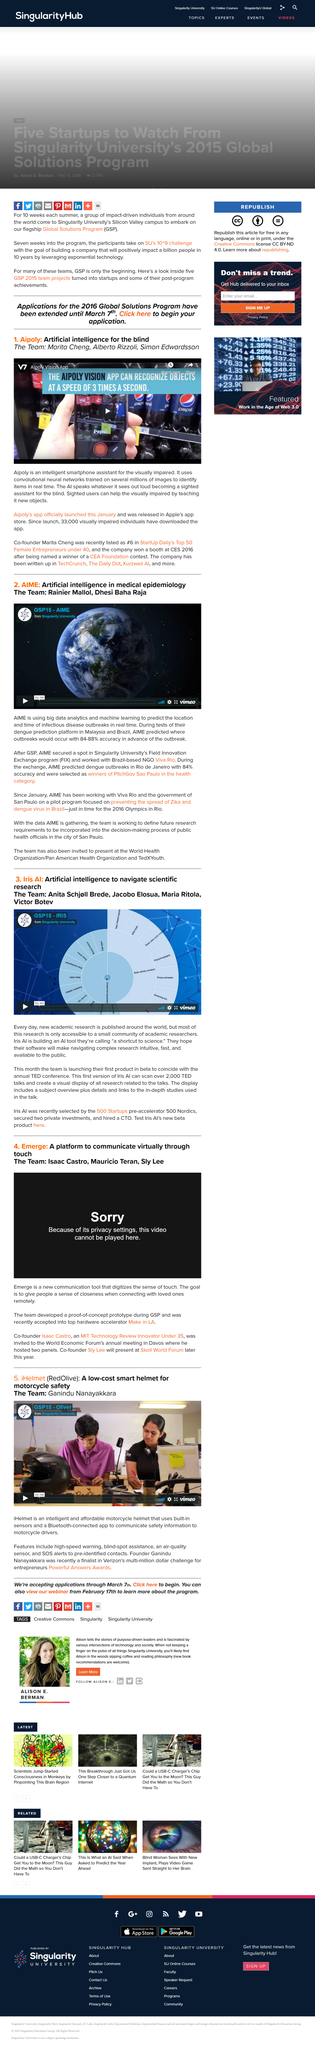Identify some key points in this picture. It has been confirmed that Sly Lee will be presenting "Emerge" at the Skoll World Forum later this year. The AIME utilizes big data analytics and machine learning to accurately predict the location and timing of infectious disease outbreaks in real time, allowing for effective prevention and control measures to be implemented. The iHelmet is a low cost smart helmet that utilizes built-in sensors. Iris AI refers to their AI tool as a convenient shortcut to scientific advancements. This article is about Aipoly, a technology that can recognize objects and perform tasks such as identifying images, reading text, and responding to voice commands. Aipoly uses artificial intelligence to analyze and process visual and auditory information, making it a versatile and powerful tool for a wide range of applications. 